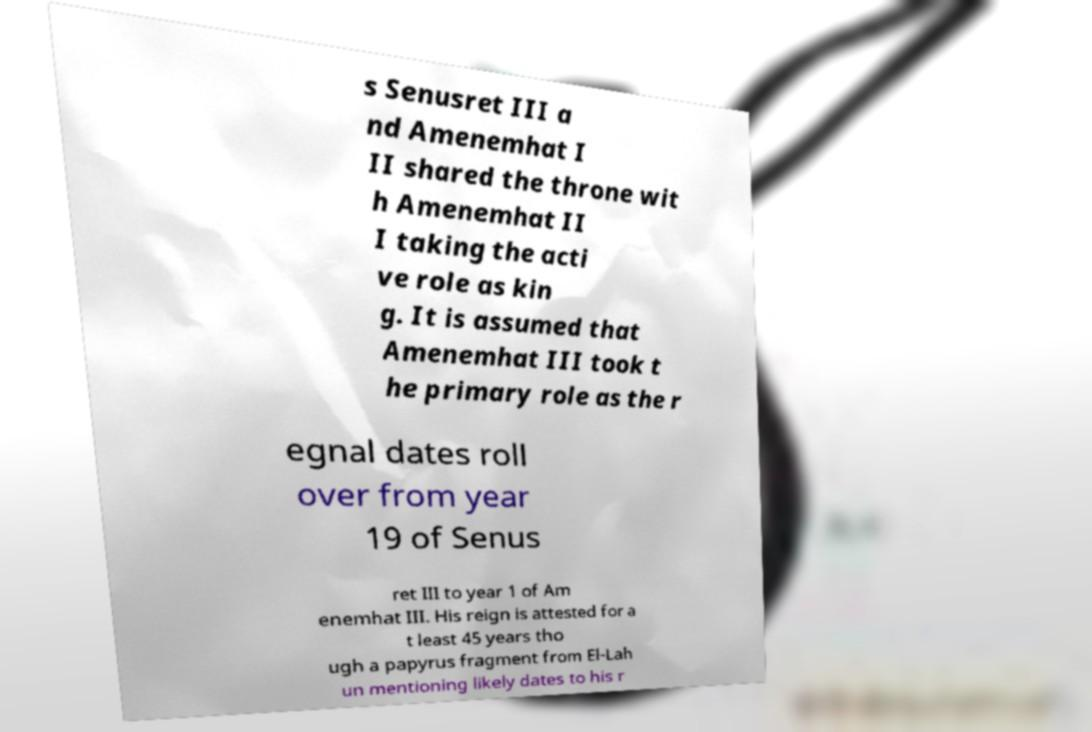Please read and relay the text visible in this image. What does it say? s Senusret III a nd Amenemhat I II shared the throne wit h Amenemhat II I taking the acti ve role as kin g. It is assumed that Amenemhat III took t he primary role as the r egnal dates roll over from year 19 of Senus ret III to year 1 of Am enemhat III. His reign is attested for a t least 45 years tho ugh a papyrus fragment from El-Lah un mentioning likely dates to his r 